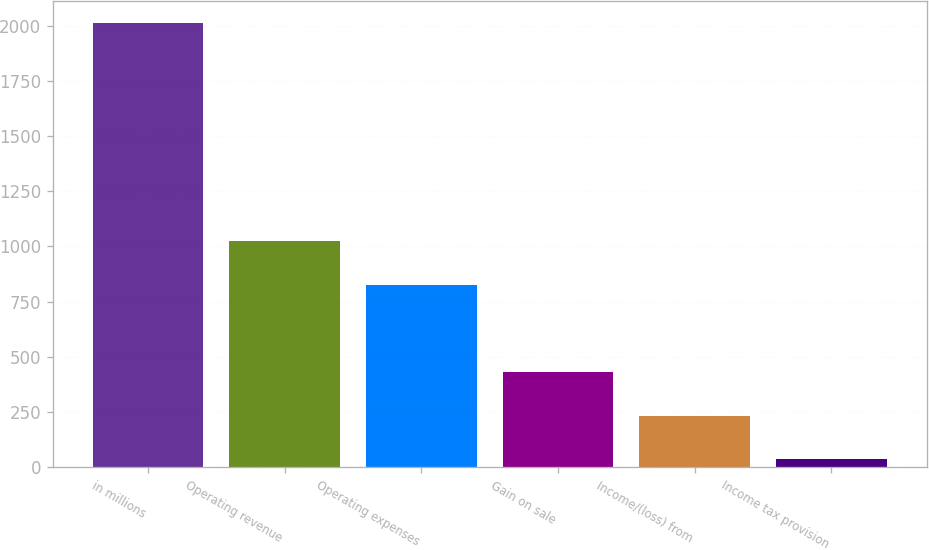Convert chart to OTSL. <chart><loc_0><loc_0><loc_500><loc_500><bar_chart><fcel>in millions<fcel>Operating revenue<fcel>Operating expenses<fcel>Gain on sale<fcel>Income/(loss) from<fcel>Income tax provision<nl><fcel>2013<fcel>1024.7<fcel>827.04<fcel>431.72<fcel>234.06<fcel>36.4<nl></chart> 